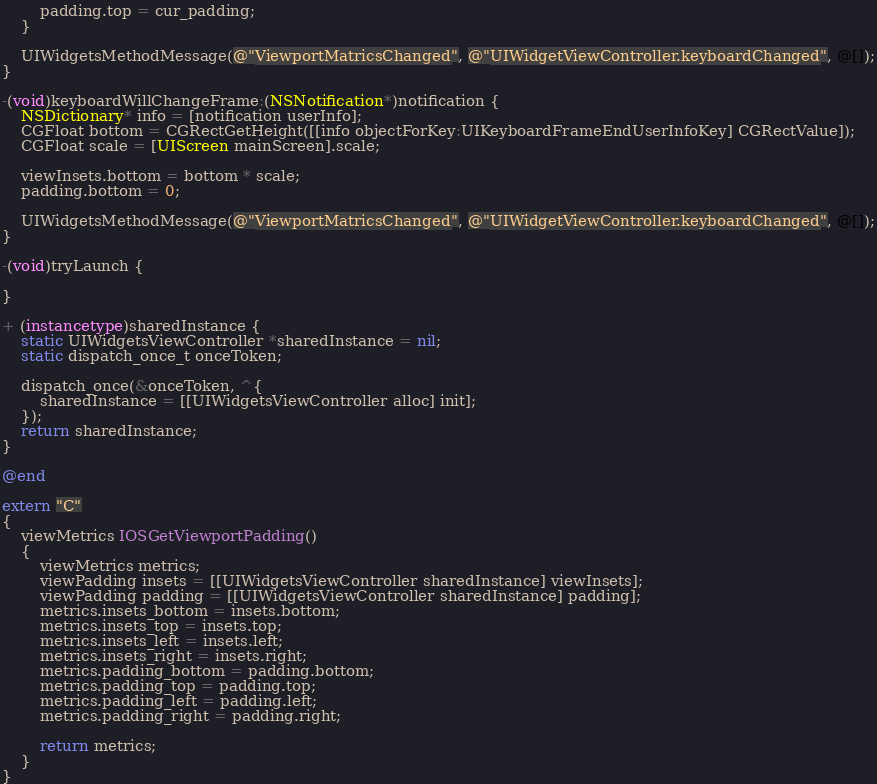Convert code to text. <code><loc_0><loc_0><loc_500><loc_500><_ObjectiveC_>        padding.top = cur_padding;
    }

    UIWidgetsMethodMessage(@"ViewportMatricsChanged", @"UIWidgetViewController.keyboardChanged", @[]);
}

-(void)keyboardWillChangeFrame:(NSNotification*)notification {
    NSDictionary* info = [notification userInfo];
    CGFloat bottom = CGRectGetHeight([[info objectForKey:UIKeyboardFrameEndUserInfoKey] CGRectValue]);
    CGFloat scale = [UIScreen mainScreen].scale;

    viewInsets.bottom = bottom * scale;
    padding.bottom = 0;

    UIWidgetsMethodMessage(@"ViewportMatricsChanged", @"UIWidgetViewController.keyboardChanged", @[]);
}

-(void)tryLaunch {

}

+ (instancetype)sharedInstance {
    static UIWidgetsViewController *sharedInstance = nil;
    static dispatch_once_t onceToken;

    dispatch_once(&onceToken, ^{
        sharedInstance = [[UIWidgetsViewController alloc] init];
    });
    return sharedInstance;
}

@end

extern "C"
{
    viewMetrics IOSGetViewportPadding()
    {
        viewMetrics metrics;
        viewPadding insets = [[UIWidgetsViewController sharedInstance] viewInsets];
        viewPadding padding = [[UIWidgetsViewController sharedInstance] padding];
        metrics.insets_bottom = insets.bottom;
        metrics.insets_top = insets.top;
        metrics.insets_left = insets.left;
        metrics.insets_right = insets.right;
        metrics.padding_bottom = padding.bottom;
        metrics.padding_top = padding.top;
        metrics.padding_left = padding.left;
        metrics.padding_right = padding.right;

        return metrics;
    }
}
</code> 